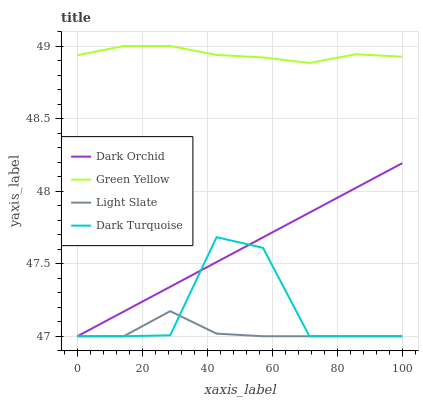Does Light Slate have the minimum area under the curve?
Answer yes or no. Yes. Does Green Yellow have the maximum area under the curve?
Answer yes or no. Yes. Does Dark Turquoise have the minimum area under the curve?
Answer yes or no. No. Does Dark Turquoise have the maximum area under the curve?
Answer yes or no. No. Is Dark Orchid the smoothest?
Answer yes or no. Yes. Is Dark Turquoise the roughest?
Answer yes or no. Yes. Is Green Yellow the smoothest?
Answer yes or no. No. Is Green Yellow the roughest?
Answer yes or no. No. Does Light Slate have the lowest value?
Answer yes or no. Yes. Does Green Yellow have the lowest value?
Answer yes or no. No. Does Green Yellow have the highest value?
Answer yes or no. Yes. Does Dark Turquoise have the highest value?
Answer yes or no. No. Is Dark Turquoise less than Green Yellow?
Answer yes or no. Yes. Is Green Yellow greater than Dark Turquoise?
Answer yes or no. Yes. Does Dark Orchid intersect Light Slate?
Answer yes or no. Yes. Is Dark Orchid less than Light Slate?
Answer yes or no. No. Is Dark Orchid greater than Light Slate?
Answer yes or no. No. Does Dark Turquoise intersect Green Yellow?
Answer yes or no. No. 